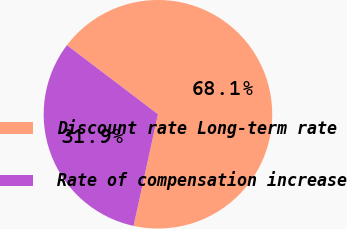Convert chart. <chart><loc_0><loc_0><loc_500><loc_500><pie_chart><fcel>Discount rate Long-term rate<fcel>Rate of compensation increase<nl><fcel>68.09%<fcel>31.91%<nl></chart> 